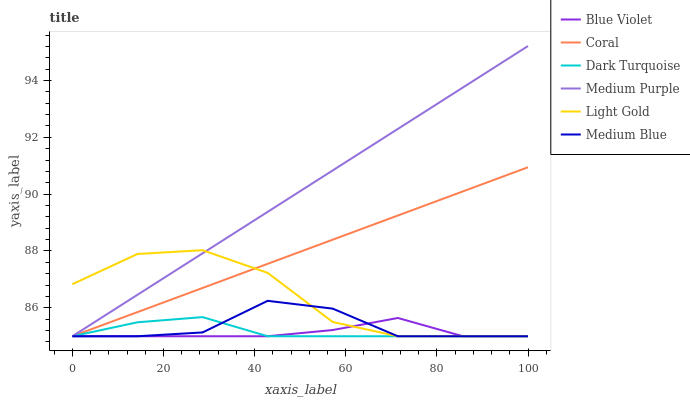Does Coral have the minimum area under the curve?
Answer yes or no. No. Does Coral have the maximum area under the curve?
Answer yes or no. No. Is Medium Blue the smoothest?
Answer yes or no. No. Is Medium Blue the roughest?
Answer yes or no. No. Does Coral have the highest value?
Answer yes or no. No. 